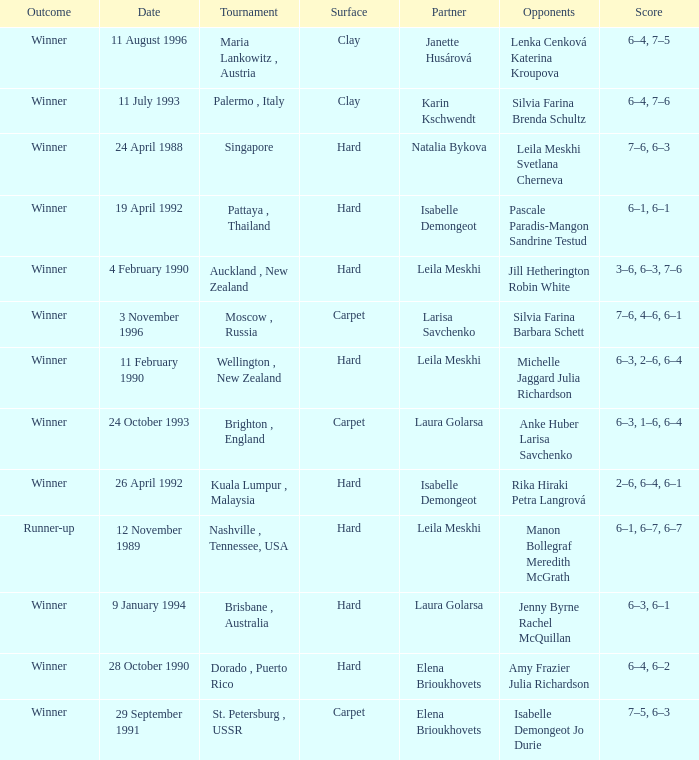Who was the Partner in a game with the Score of 6–4, 6–2 on a hard surface? Elena Brioukhovets. 